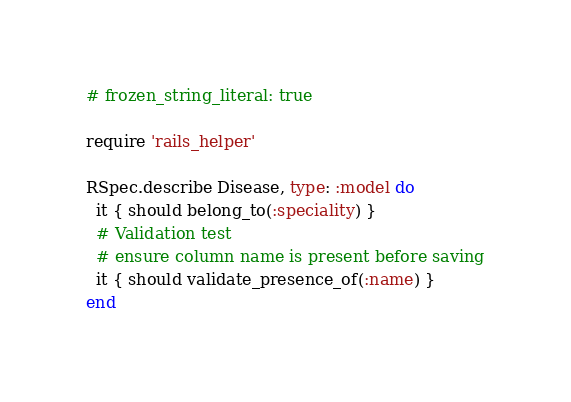<code> <loc_0><loc_0><loc_500><loc_500><_Ruby_># frozen_string_literal: true

require 'rails_helper'

RSpec.describe Disease, type: :model do
  it { should belong_to(:speciality) }
  # Validation test
  # ensure column name is present before saving
  it { should validate_presence_of(:name) }
end
</code> 